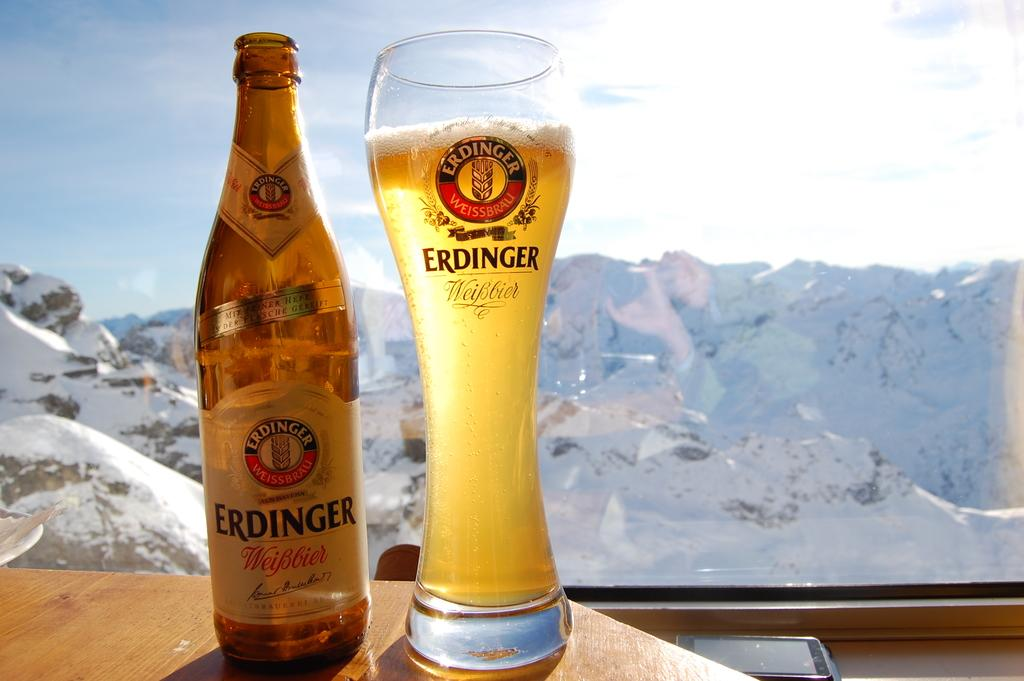<image>
Give a short and clear explanation of the subsequent image. A bottle and a glass of Erdinger beer placed side by side. 